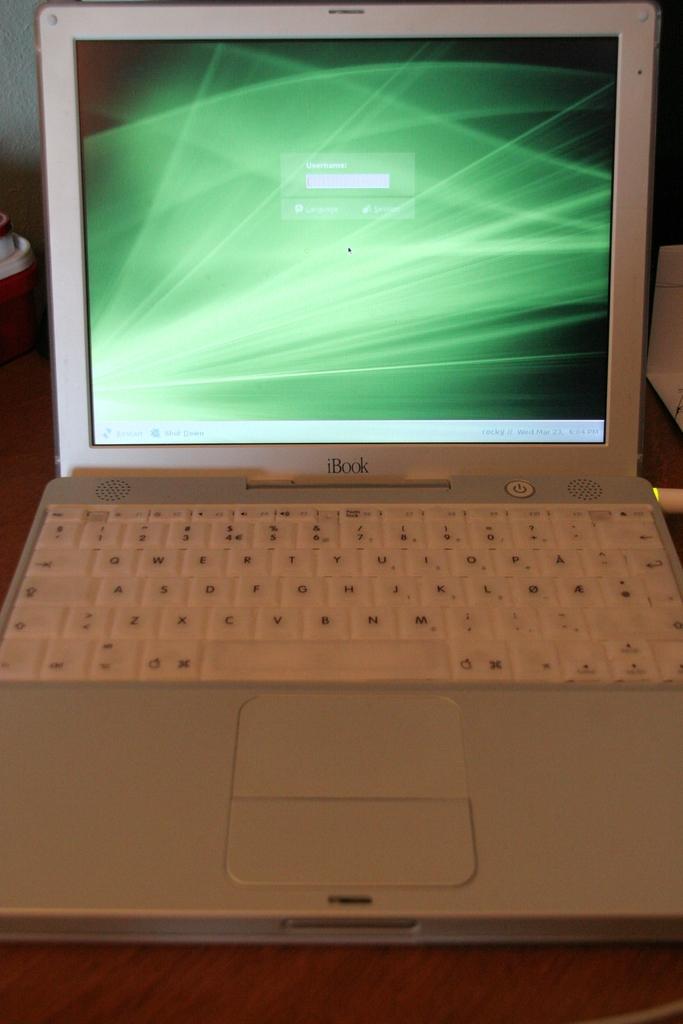The screen is too far away to read, what does it say on the screen?
Provide a short and direct response. Username. What type of laptop is this?
Your answer should be very brief. Ibook. 